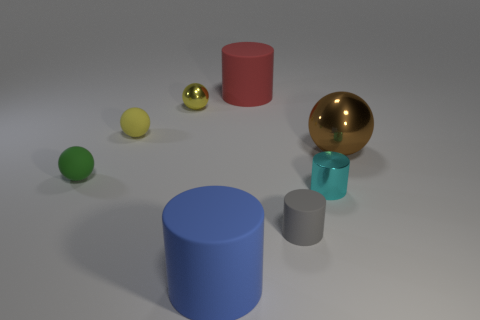There is a green object that is made of the same material as the gray thing; what is its size?
Your response must be concise. Small. What number of blue things are either matte balls or small objects?
Offer a very short reply. 0. There is a small object that is the same color as the tiny metallic ball; what is its shape?
Ensure brevity in your answer.  Sphere. Is there anything else that is the same material as the cyan cylinder?
Provide a short and direct response. Yes. There is a big object that is behind the brown metal object; does it have the same shape as the large object that is in front of the cyan metallic thing?
Offer a very short reply. Yes. How many small gray objects are there?
Your answer should be very brief. 1. There is a red thing that is made of the same material as the big blue cylinder; what is its shape?
Keep it short and to the point. Cylinder. Are there any other things that have the same color as the metal cylinder?
Give a very brief answer. No. Does the large shiny ball have the same color as the matte cylinder that is behind the cyan thing?
Keep it short and to the point. No. Are there fewer big objects that are left of the yellow matte sphere than big yellow metallic cylinders?
Your answer should be compact. No. 